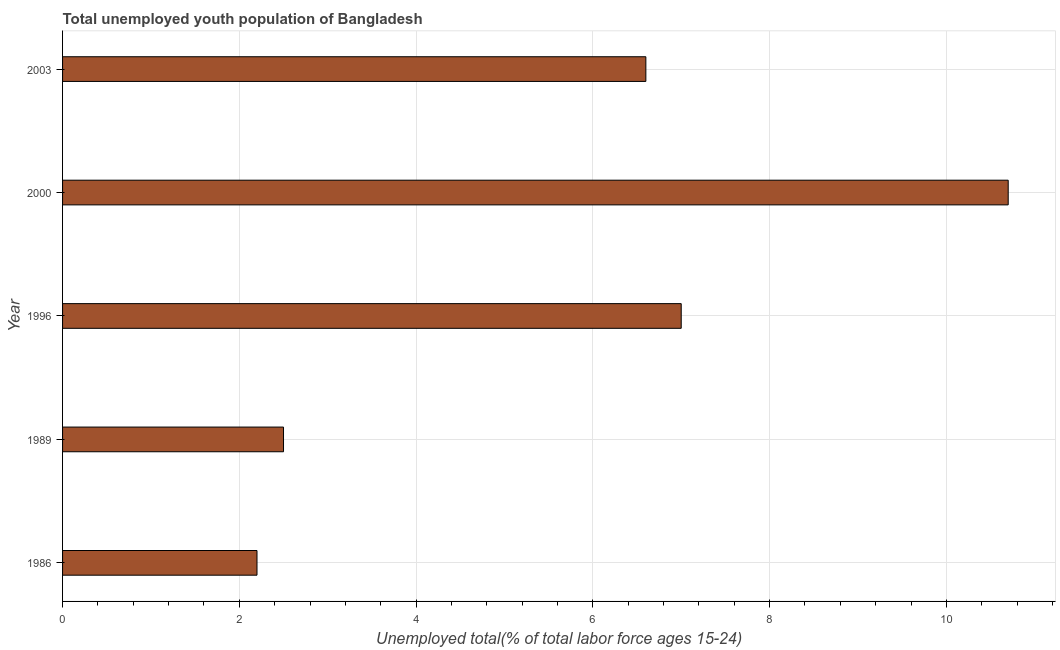What is the title of the graph?
Provide a succinct answer. Total unemployed youth population of Bangladesh. What is the label or title of the X-axis?
Give a very brief answer. Unemployed total(% of total labor force ages 15-24). What is the label or title of the Y-axis?
Ensure brevity in your answer.  Year. What is the unemployed youth in 1986?
Keep it short and to the point. 2.2. Across all years, what is the maximum unemployed youth?
Make the answer very short. 10.7. Across all years, what is the minimum unemployed youth?
Make the answer very short. 2.2. In which year was the unemployed youth maximum?
Keep it short and to the point. 2000. In which year was the unemployed youth minimum?
Provide a succinct answer. 1986. What is the sum of the unemployed youth?
Your answer should be compact. 29. What is the average unemployed youth per year?
Keep it short and to the point. 5.8. What is the median unemployed youth?
Your response must be concise. 6.6. Do a majority of the years between 2003 and 1996 (inclusive) have unemployed youth greater than 4 %?
Your answer should be compact. Yes. What is the ratio of the unemployed youth in 1996 to that in 2003?
Offer a very short reply. 1.06. What is the difference between the highest and the second highest unemployed youth?
Offer a very short reply. 3.7. In how many years, is the unemployed youth greater than the average unemployed youth taken over all years?
Your response must be concise. 3. How many bars are there?
Make the answer very short. 5. How many years are there in the graph?
Keep it short and to the point. 5. What is the difference between two consecutive major ticks on the X-axis?
Provide a short and direct response. 2. What is the Unemployed total(% of total labor force ages 15-24) of 1986?
Your answer should be very brief. 2.2. What is the Unemployed total(% of total labor force ages 15-24) in 1989?
Your answer should be very brief. 2.5. What is the Unemployed total(% of total labor force ages 15-24) of 1996?
Keep it short and to the point. 7. What is the Unemployed total(% of total labor force ages 15-24) of 2000?
Give a very brief answer. 10.7. What is the Unemployed total(% of total labor force ages 15-24) in 2003?
Give a very brief answer. 6.6. What is the difference between the Unemployed total(% of total labor force ages 15-24) in 1986 and 2000?
Offer a terse response. -8.5. What is the difference between the Unemployed total(% of total labor force ages 15-24) in 1989 and 1996?
Your response must be concise. -4.5. What is the difference between the Unemployed total(% of total labor force ages 15-24) in 1989 and 2003?
Your answer should be compact. -4.1. What is the difference between the Unemployed total(% of total labor force ages 15-24) in 1996 and 2000?
Provide a short and direct response. -3.7. What is the difference between the Unemployed total(% of total labor force ages 15-24) in 2000 and 2003?
Ensure brevity in your answer.  4.1. What is the ratio of the Unemployed total(% of total labor force ages 15-24) in 1986 to that in 1996?
Ensure brevity in your answer.  0.31. What is the ratio of the Unemployed total(% of total labor force ages 15-24) in 1986 to that in 2000?
Provide a short and direct response. 0.21. What is the ratio of the Unemployed total(% of total labor force ages 15-24) in 1986 to that in 2003?
Ensure brevity in your answer.  0.33. What is the ratio of the Unemployed total(% of total labor force ages 15-24) in 1989 to that in 1996?
Offer a terse response. 0.36. What is the ratio of the Unemployed total(% of total labor force ages 15-24) in 1989 to that in 2000?
Make the answer very short. 0.23. What is the ratio of the Unemployed total(% of total labor force ages 15-24) in 1989 to that in 2003?
Ensure brevity in your answer.  0.38. What is the ratio of the Unemployed total(% of total labor force ages 15-24) in 1996 to that in 2000?
Offer a terse response. 0.65. What is the ratio of the Unemployed total(% of total labor force ages 15-24) in 1996 to that in 2003?
Your answer should be compact. 1.06. What is the ratio of the Unemployed total(% of total labor force ages 15-24) in 2000 to that in 2003?
Give a very brief answer. 1.62. 